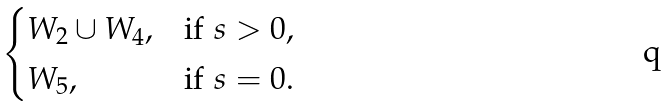Convert formula to latex. <formula><loc_0><loc_0><loc_500><loc_500>\begin{cases} W _ { 2 } \cup W _ { 4 } , & \text {if } s > 0 , \\ W _ { 5 } , & \text {if } s = 0 . \end{cases}</formula> 